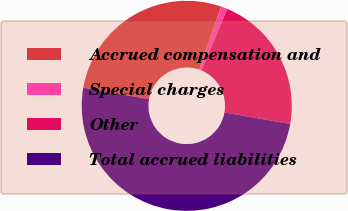<chart> <loc_0><loc_0><loc_500><loc_500><pie_chart><fcel>Accrued compensation and<fcel>Special charges<fcel>Other<fcel>Total accrued liabilities<nl><fcel>27.54%<fcel>1.0%<fcel>21.45%<fcel>50.0%<nl></chart> 